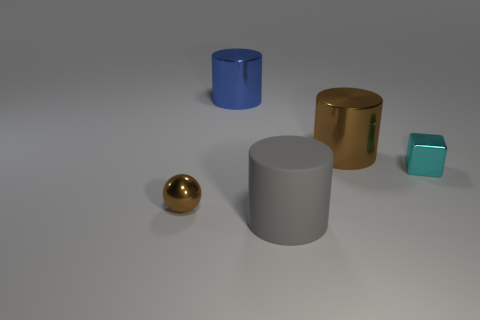Add 1 small gray metal cylinders. How many objects exist? 6 Subtract all blocks. How many objects are left? 4 Add 5 cyan objects. How many cyan objects exist? 6 Subtract 1 brown balls. How many objects are left? 4 Subtract all rubber cylinders. Subtract all metallic things. How many objects are left? 0 Add 3 big gray rubber cylinders. How many big gray rubber cylinders are left? 4 